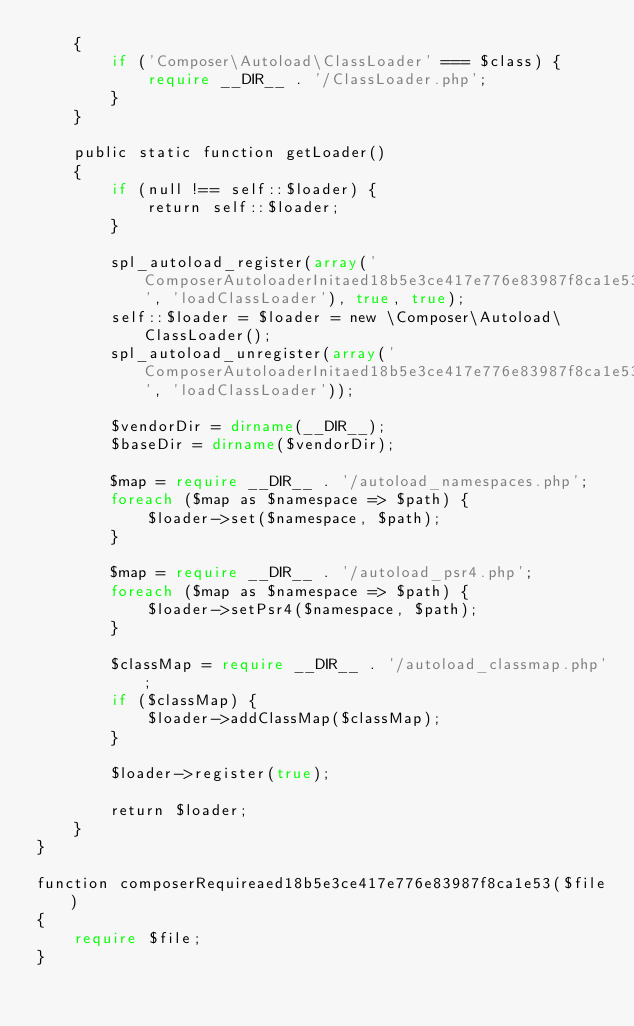<code> <loc_0><loc_0><loc_500><loc_500><_PHP_>    {
        if ('Composer\Autoload\ClassLoader' === $class) {
            require __DIR__ . '/ClassLoader.php';
        }
    }

    public static function getLoader()
    {
        if (null !== self::$loader) {
            return self::$loader;
        }

        spl_autoload_register(array('ComposerAutoloaderInitaed18b5e3ce417e776e83987f8ca1e53', 'loadClassLoader'), true, true);
        self::$loader = $loader = new \Composer\Autoload\ClassLoader();
        spl_autoload_unregister(array('ComposerAutoloaderInitaed18b5e3ce417e776e83987f8ca1e53', 'loadClassLoader'));

        $vendorDir = dirname(__DIR__);
        $baseDir = dirname($vendorDir);

        $map = require __DIR__ . '/autoload_namespaces.php';
        foreach ($map as $namespace => $path) {
            $loader->set($namespace, $path);
        }

        $map = require __DIR__ . '/autoload_psr4.php';
        foreach ($map as $namespace => $path) {
            $loader->setPsr4($namespace, $path);
        }

        $classMap = require __DIR__ . '/autoload_classmap.php';
        if ($classMap) {
            $loader->addClassMap($classMap);
        }

        $loader->register(true);

        return $loader;
    }
}

function composerRequireaed18b5e3ce417e776e83987f8ca1e53($file)
{
    require $file;
}
</code> 